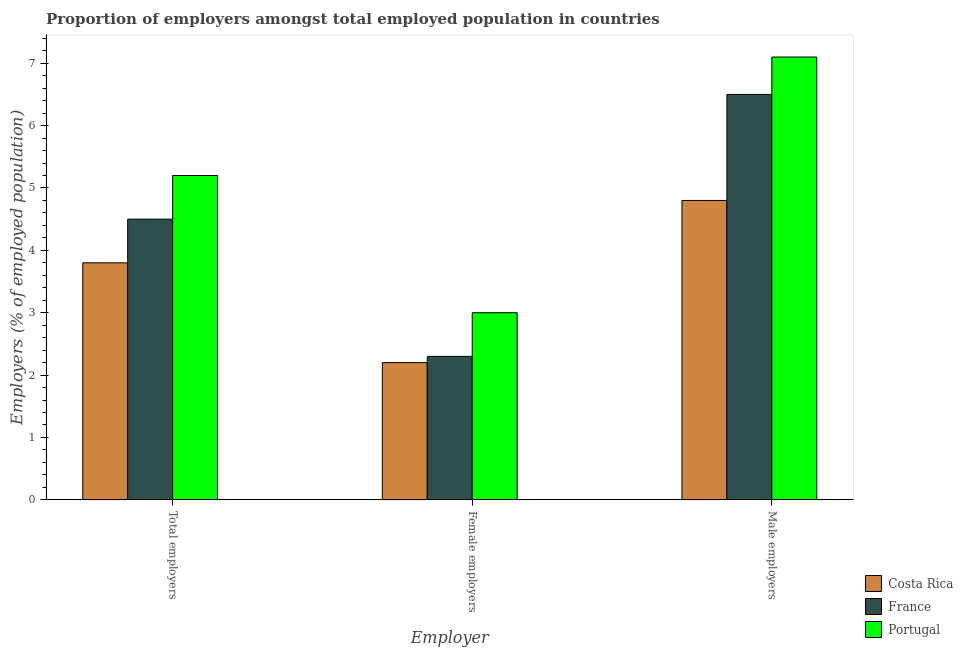How many groups of bars are there?
Provide a succinct answer. 3. Are the number of bars per tick equal to the number of legend labels?
Your answer should be compact. Yes. How many bars are there on the 1st tick from the right?
Keep it short and to the point. 3. What is the label of the 3rd group of bars from the left?
Provide a short and direct response. Male employers. What is the percentage of male employers in Costa Rica?
Keep it short and to the point. 4.8. Across all countries, what is the maximum percentage of male employers?
Your answer should be very brief. 7.1. Across all countries, what is the minimum percentage of total employers?
Provide a succinct answer. 3.8. In which country was the percentage of total employers maximum?
Keep it short and to the point. Portugal. In which country was the percentage of male employers minimum?
Your answer should be compact. Costa Rica. What is the total percentage of female employers in the graph?
Your response must be concise. 7.5. What is the difference between the percentage of female employers in France and that in Portugal?
Keep it short and to the point. -0.7. What is the difference between the percentage of male employers in Costa Rica and the percentage of total employers in Portugal?
Your answer should be very brief. -0.4. What is the average percentage of total employers per country?
Offer a terse response. 4.5. What is the difference between the percentage of male employers and percentage of total employers in Portugal?
Offer a terse response. 1.9. In how many countries, is the percentage of female employers greater than 7.2 %?
Keep it short and to the point. 0. What is the ratio of the percentage of male employers in France to that in Costa Rica?
Ensure brevity in your answer.  1.35. Is the difference between the percentage of male employers in Portugal and France greater than the difference between the percentage of total employers in Portugal and France?
Make the answer very short. No. What is the difference between the highest and the second highest percentage of female employers?
Your response must be concise. 0.7. What is the difference between the highest and the lowest percentage of total employers?
Offer a very short reply. 1.4. In how many countries, is the percentage of male employers greater than the average percentage of male employers taken over all countries?
Your answer should be very brief. 2. Is the sum of the percentage of total employers in France and Costa Rica greater than the maximum percentage of male employers across all countries?
Your answer should be compact. Yes. What does the 3rd bar from the left in Female employers represents?
Make the answer very short. Portugal. Are all the bars in the graph horizontal?
Offer a terse response. No. How many countries are there in the graph?
Your answer should be compact. 3. What is the difference between two consecutive major ticks on the Y-axis?
Your answer should be compact. 1. Does the graph contain any zero values?
Your answer should be very brief. No. Does the graph contain grids?
Provide a short and direct response. No. How many legend labels are there?
Give a very brief answer. 3. What is the title of the graph?
Make the answer very short. Proportion of employers amongst total employed population in countries. Does "Greece" appear as one of the legend labels in the graph?
Provide a short and direct response. No. What is the label or title of the X-axis?
Ensure brevity in your answer.  Employer. What is the label or title of the Y-axis?
Your response must be concise. Employers (% of employed population). What is the Employers (% of employed population) of Costa Rica in Total employers?
Make the answer very short. 3.8. What is the Employers (% of employed population) of Portugal in Total employers?
Provide a succinct answer. 5.2. What is the Employers (% of employed population) in Costa Rica in Female employers?
Provide a short and direct response. 2.2. What is the Employers (% of employed population) in France in Female employers?
Your answer should be very brief. 2.3. What is the Employers (% of employed population) in Portugal in Female employers?
Keep it short and to the point. 3. What is the Employers (% of employed population) in Costa Rica in Male employers?
Make the answer very short. 4.8. What is the Employers (% of employed population) in France in Male employers?
Your answer should be compact. 6.5. What is the Employers (% of employed population) in Portugal in Male employers?
Your response must be concise. 7.1. Across all Employer, what is the maximum Employers (% of employed population) of Costa Rica?
Your response must be concise. 4.8. Across all Employer, what is the maximum Employers (% of employed population) of Portugal?
Your answer should be very brief. 7.1. Across all Employer, what is the minimum Employers (% of employed population) in Costa Rica?
Ensure brevity in your answer.  2.2. Across all Employer, what is the minimum Employers (% of employed population) in France?
Give a very brief answer. 2.3. What is the difference between the Employers (% of employed population) of Portugal in Total employers and that in Female employers?
Keep it short and to the point. 2.2. What is the difference between the Employers (% of employed population) in Portugal in Total employers and that in Male employers?
Ensure brevity in your answer.  -1.9. What is the difference between the Employers (% of employed population) of Costa Rica in Female employers and that in Male employers?
Give a very brief answer. -2.6. What is the difference between the Employers (% of employed population) of France in Total employers and the Employers (% of employed population) of Portugal in Female employers?
Your answer should be very brief. 1.5. What is the difference between the Employers (% of employed population) in France in Female employers and the Employers (% of employed population) in Portugal in Male employers?
Give a very brief answer. -4.8. What is the average Employers (% of employed population) of France per Employer?
Your response must be concise. 4.43. What is the difference between the Employers (% of employed population) of France and Employers (% of employed population) of Portugal in Total employers?
Offer a very short reply. -0.7. What is the difference between the Employers (% of employed population) of Costa Rica and Employers (% of employed population) of France in Female employers?
Provide a short and direct response. -0.1. What is the difference between the Employers (% of employed population) of Costa Rica and Employers (% of employed population) of Portugal in Female employers?
Offer a terse response. -0.8. What is the difference between the Employers (% of employed population) in France and Employers (% of employed population) in Portugal in Female employers?
Offer a terse response. -0.7. What is the difference between the Employers (% of employed population) in Costa Rica and Employers (% of employed population) in Portugal in Male employers?
Make the answer very short. -2.3. What is the difference between the Employers (% of employed population) of France and Employers (% of employed population) of Portugal in Male employers?
Offer a terse response. -0.6. What is the ratio of the Employers (% of employed population) in Costa Rica in Total employers to that in Female employers?
Make the answer very short. 1.73. What is the ratio of the Employers (% of employed population) in France in Total employers to that in Female employers?
Offer a very short reply. 1.96. What is the ratio of the Employers (% of employed population) in Portugal in Total employers to that in Female employers?
Offer a terse response. 1.73. What is the ratio of the Employers (% of employed population) in Costa Rica in Total employers to that in Male employers?
Ensure brevity in your answer.  0.79. What is the ratio of the Employers (% of employed population) of France in Total employers to that in Male employers?
Make the answer very short. 0.69. What is the ratio of the Employers (% of employed population) of Portugal in Total employers to that in Male employers?
Keep it short and to the point. 0.73. What is the ratio of the Employers (% of employed population) in Costa Rica in Female employers to that in Male employers?
Your answer should be compact. 0.46. What is the ratio of the Employers (% of employed population) in France in Female employers to that in Male employers?
Give a very brief answer. 0.35. What is the ratio of the Employers (% of employed population) in Portugal in Female employers to that in Male employers?
Provide a succinct answer. 0.42. What is the difference between the highest and the second highest Employers (% of employed population) in Portugal?
Provide a short and direct response. 1.9. 